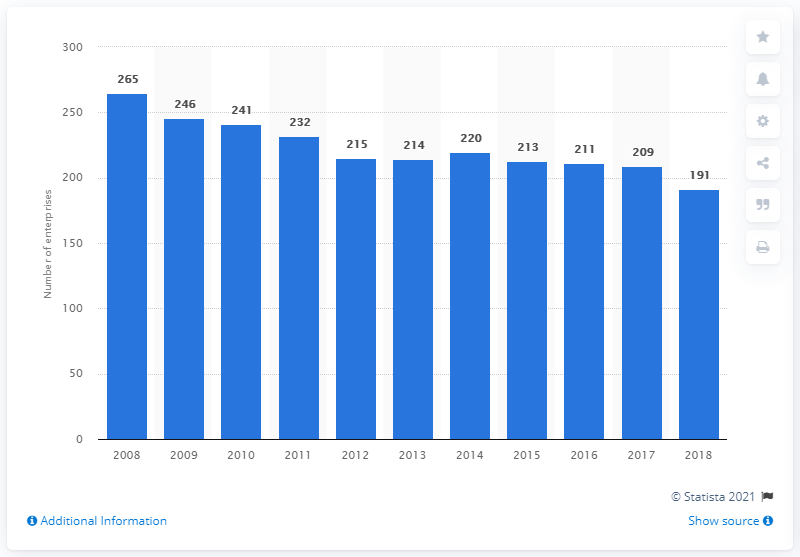Mention a couple of crucial points in this snapshot. In 2018, there were 191 enterprises in Bulgaria's manufacturing sector. 